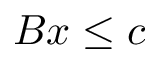<formula> <loc_0><loc_0><loc_500><loc_500>B x \leq c</formula> 